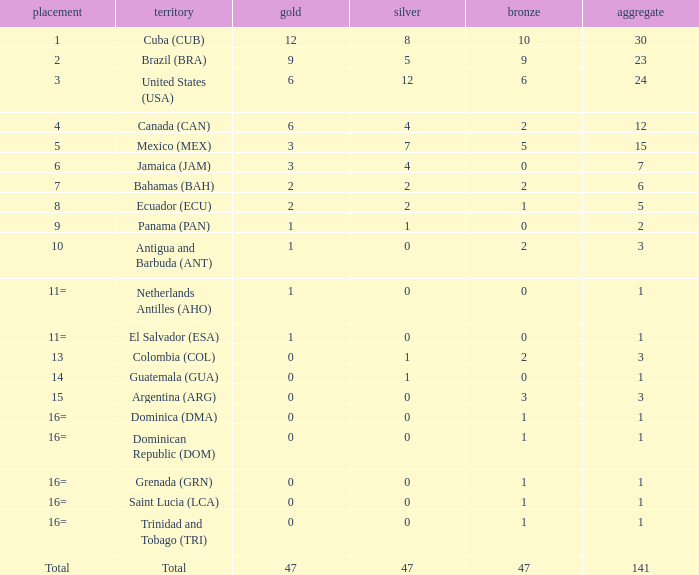How many bronzes have a Nation of jamaica (jam), and a Total smaller than 7? 0.0. 